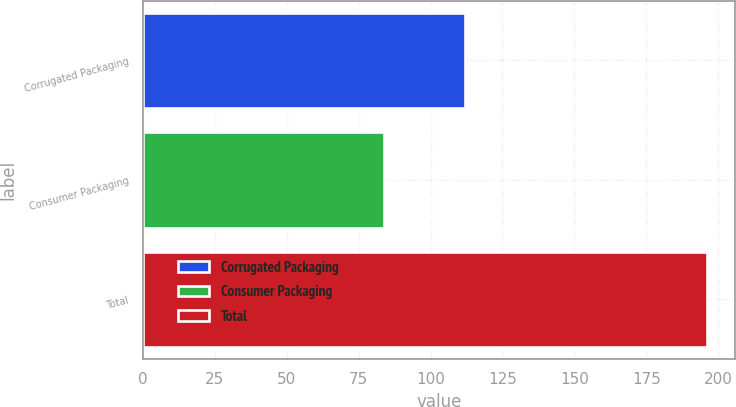<chart> <loc_0><loc_0><loc_500><loc_500><bar_chart><fcel>Corrugated Packaging<fcel>Consumer Packaging<fcel>Total<nl><fcel>112<fcel>84<fcel>196<nl></chart> 